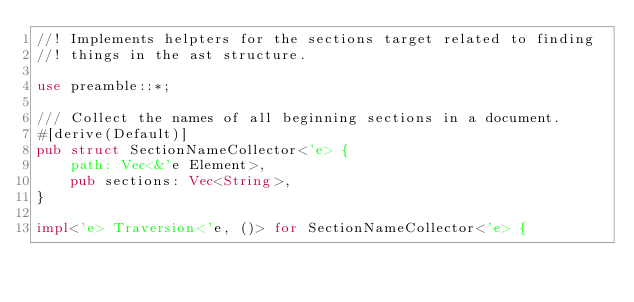Convert code to text. <code><loc_0><loc_0><loc_500><loc_500><_Rust_>//! Implements helpters for the sections target related to finding
//! things in the ast structure.

use preamble::*;

/// Collect the names of all beginning sections in a document.
#[derive(Default)]
pub struct SectionNameCollector<'e> {
    path: Vec<&'e Element>,
    pub sections: Vec<String>,
}

impl<'e> Traversion<'e, ()> for SectionNameCollector<'e> {</code> 